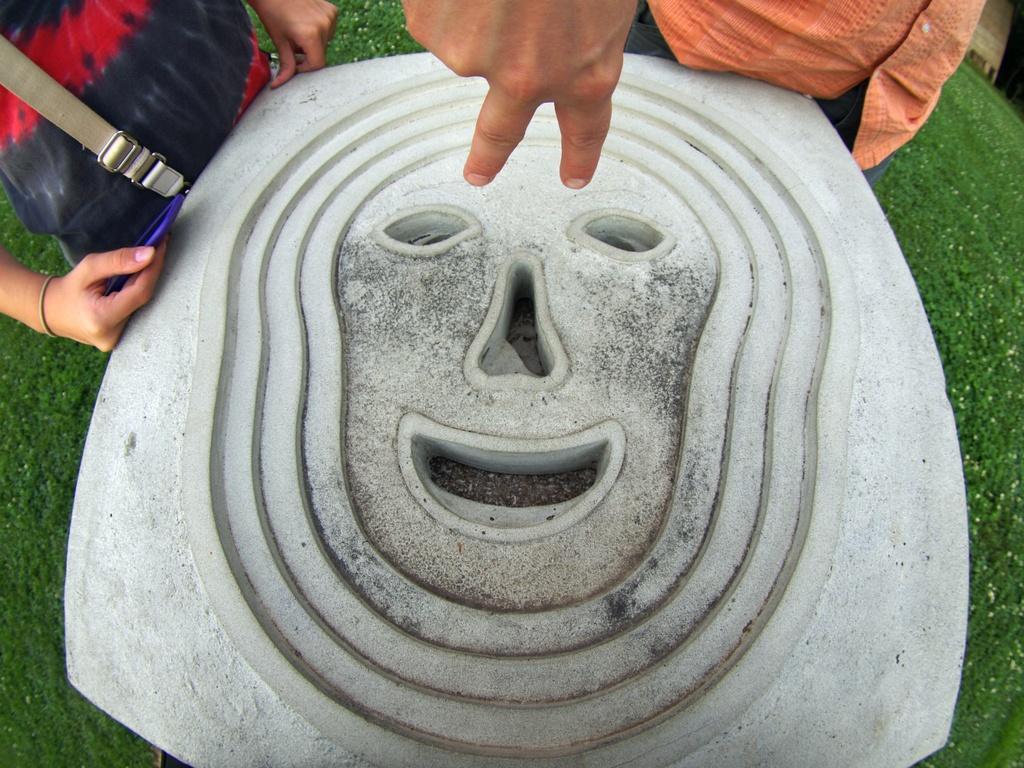Can you describe this image briefly? In this image there is a rock structure, on which there is a nose, eyes and a mouth, which is placed on the surface of the grass, in front of that there are two persons standing, one of them is holding an object. 